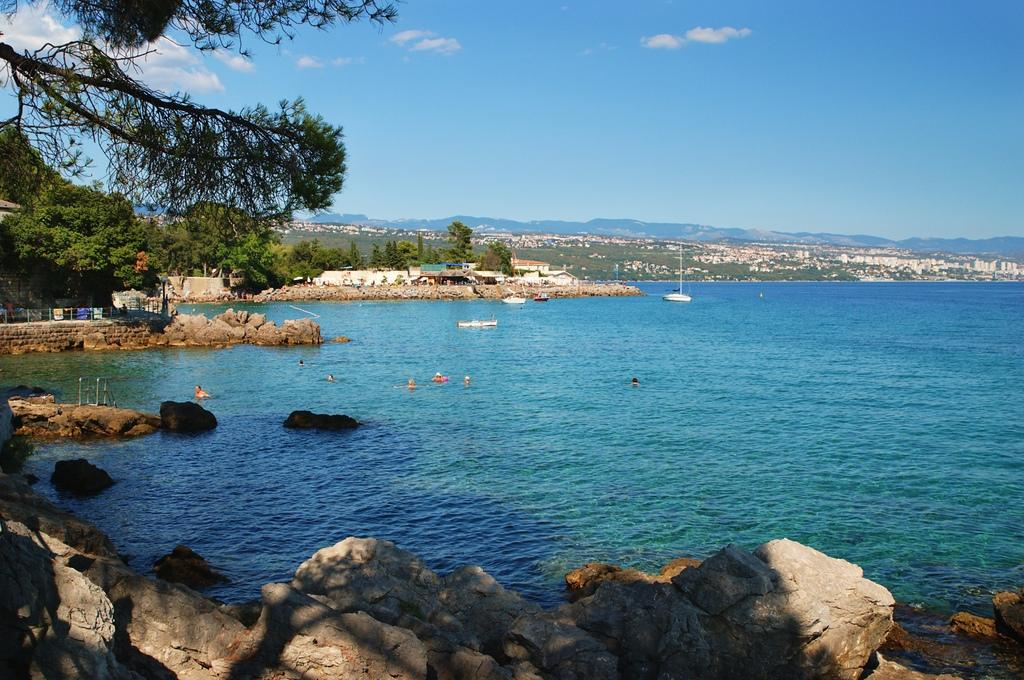What is the main feature of the image? There is water in the image. What is on the water in the image? There is a boat on the water. What can be seen at the bottom of the image? Rocks are present at the bottom of the image. What is visible in the background of the image? There are trees, hills, and the sky visible in the background of the image. What type of wound can be seen on the boat in the image? There is no wound present on the boat in the image. How far away is the weather system visible in the image? There is no weather system visible in the image; only the sky is visible in the background. 